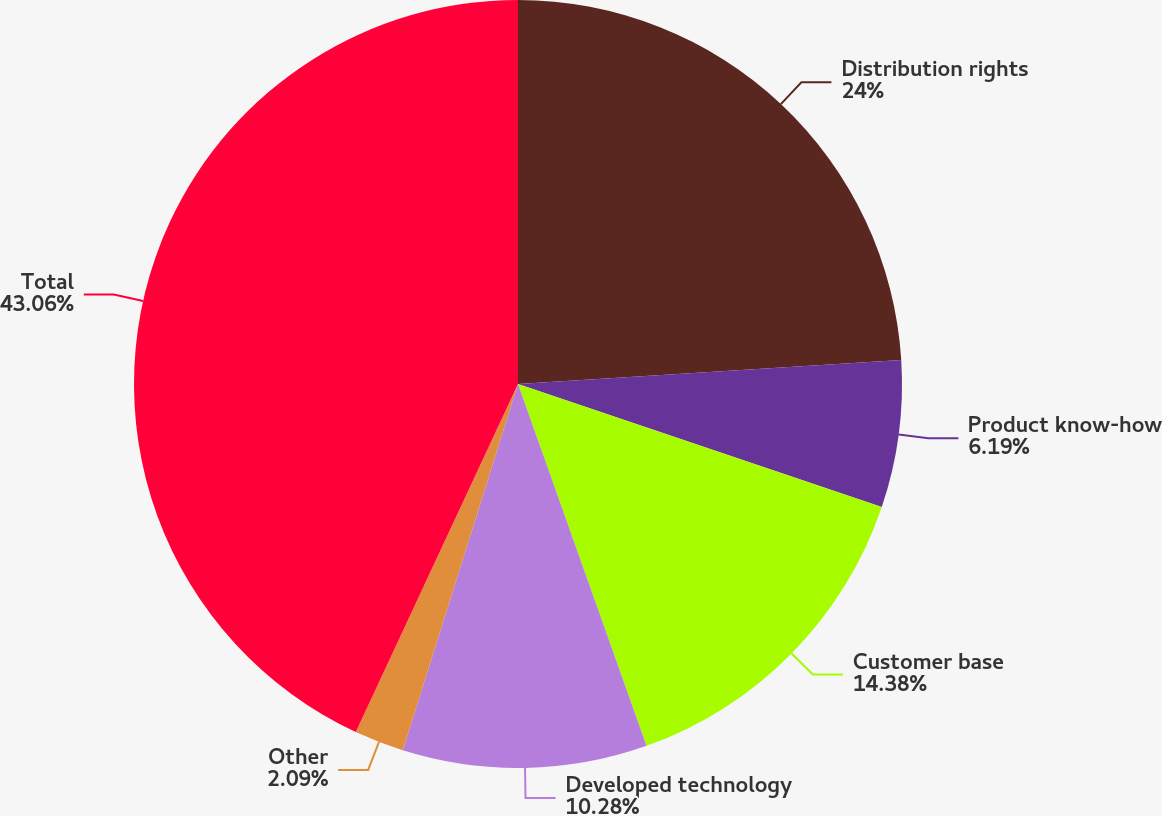Convert chart. <chart><loc_0><loc_0><loc_500><loc_500><pie_chart><fcel>Distribution rights<fcel>Product know-how<fcel>Customer base<fcel>Developed technology<fcel>Other<fcel>Total<nl><fcel>24.0%<fcel>6.19%<fcel>14.38%<fcel>10.28%<fcel>2.09%<fcel>43.06%<nl></chart> 